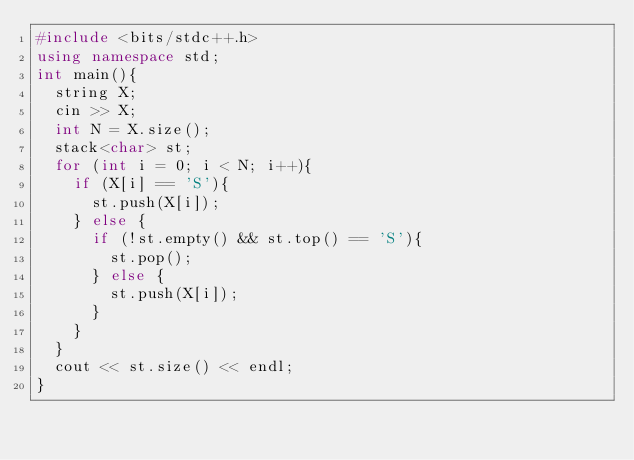Convert code to text. <code><loc_0><loc_0><loc_500><loc_500><_C++_>#include <bits/stdc++.h>
using namespace std;
int main(){
  string X;
  cin >> X;
  int N = X.size();
  stack<char> st;
  for (int i = 0; i < N; i++){
    if (X[i] == 'S'){
      st.push(X[i]);
    } else {
      if (!st.empty() && st.top() == 'S'){
        st.pop();
      } else {
        st.push(X[i]);
      }
    }
  }
  cout << st.size() << endl;
}</code> 